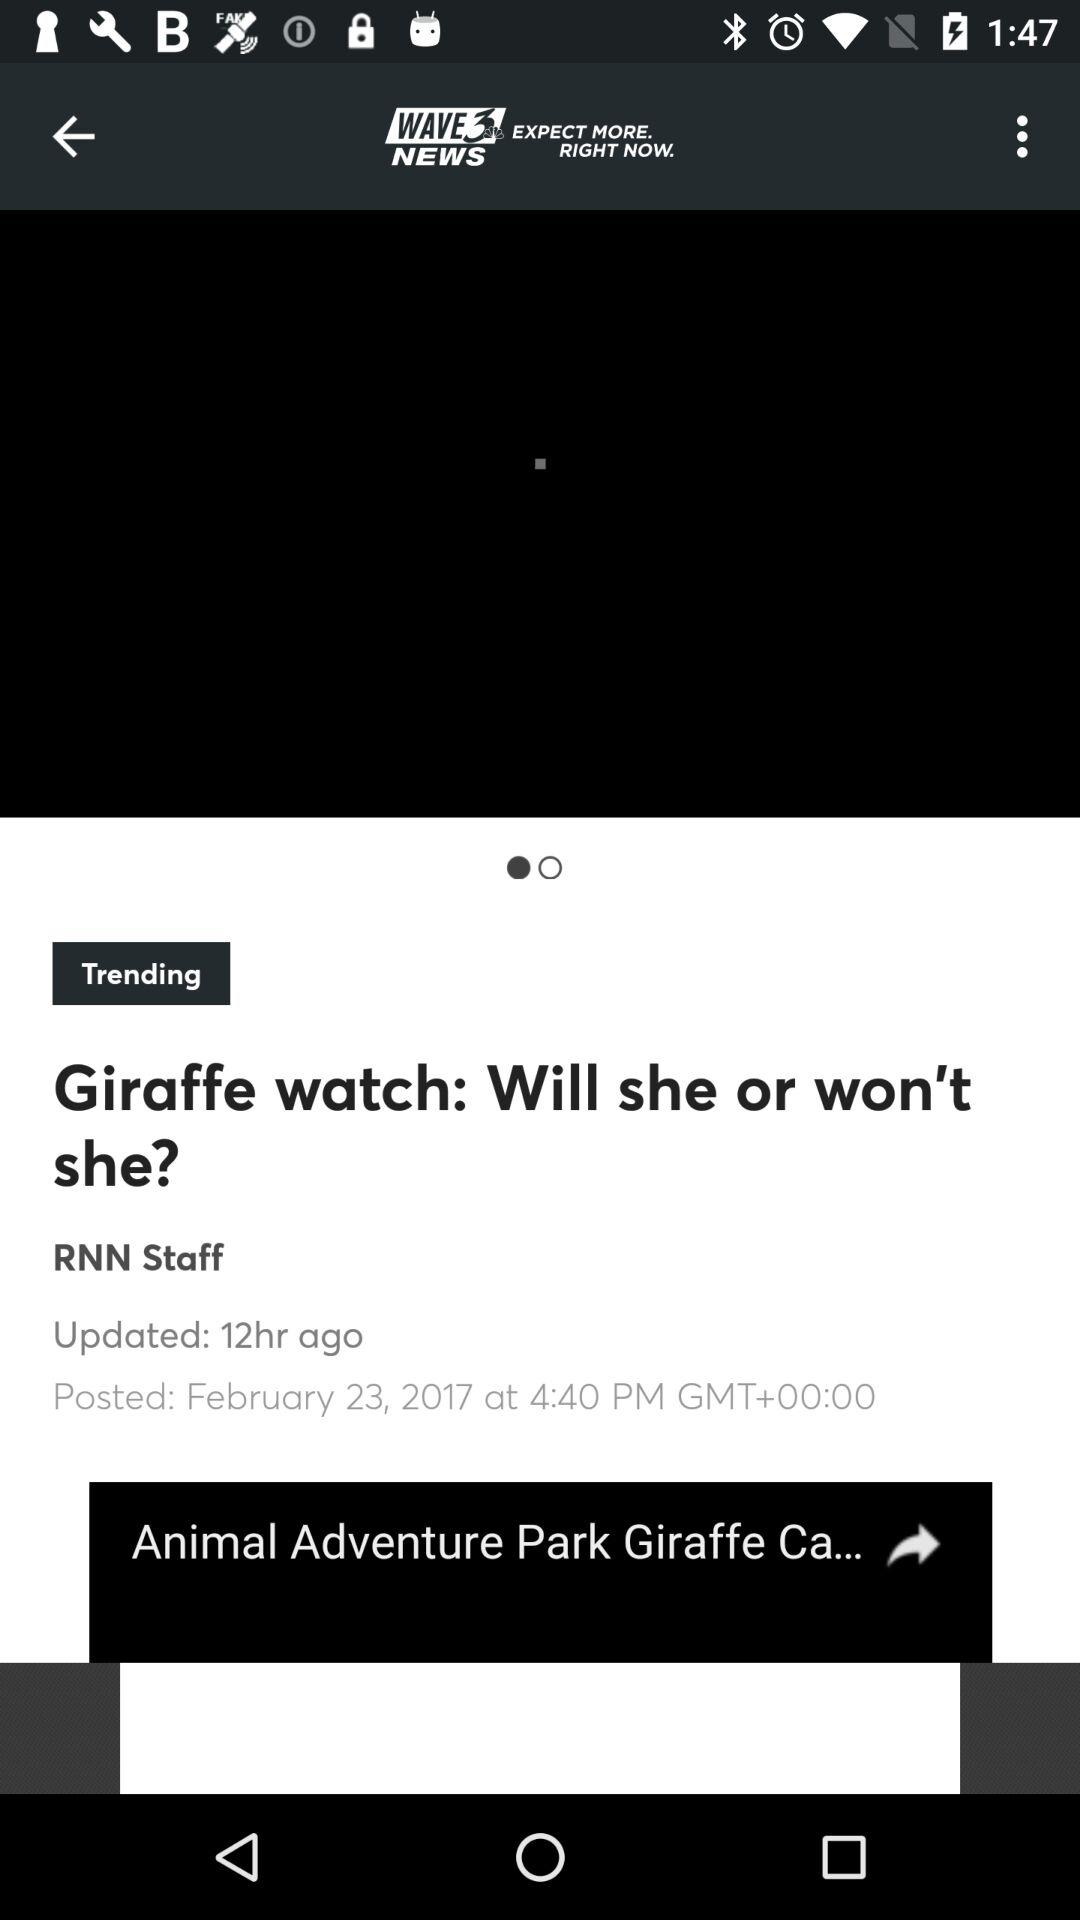At what time was the article updated? The article was updated 12 hours ago. 